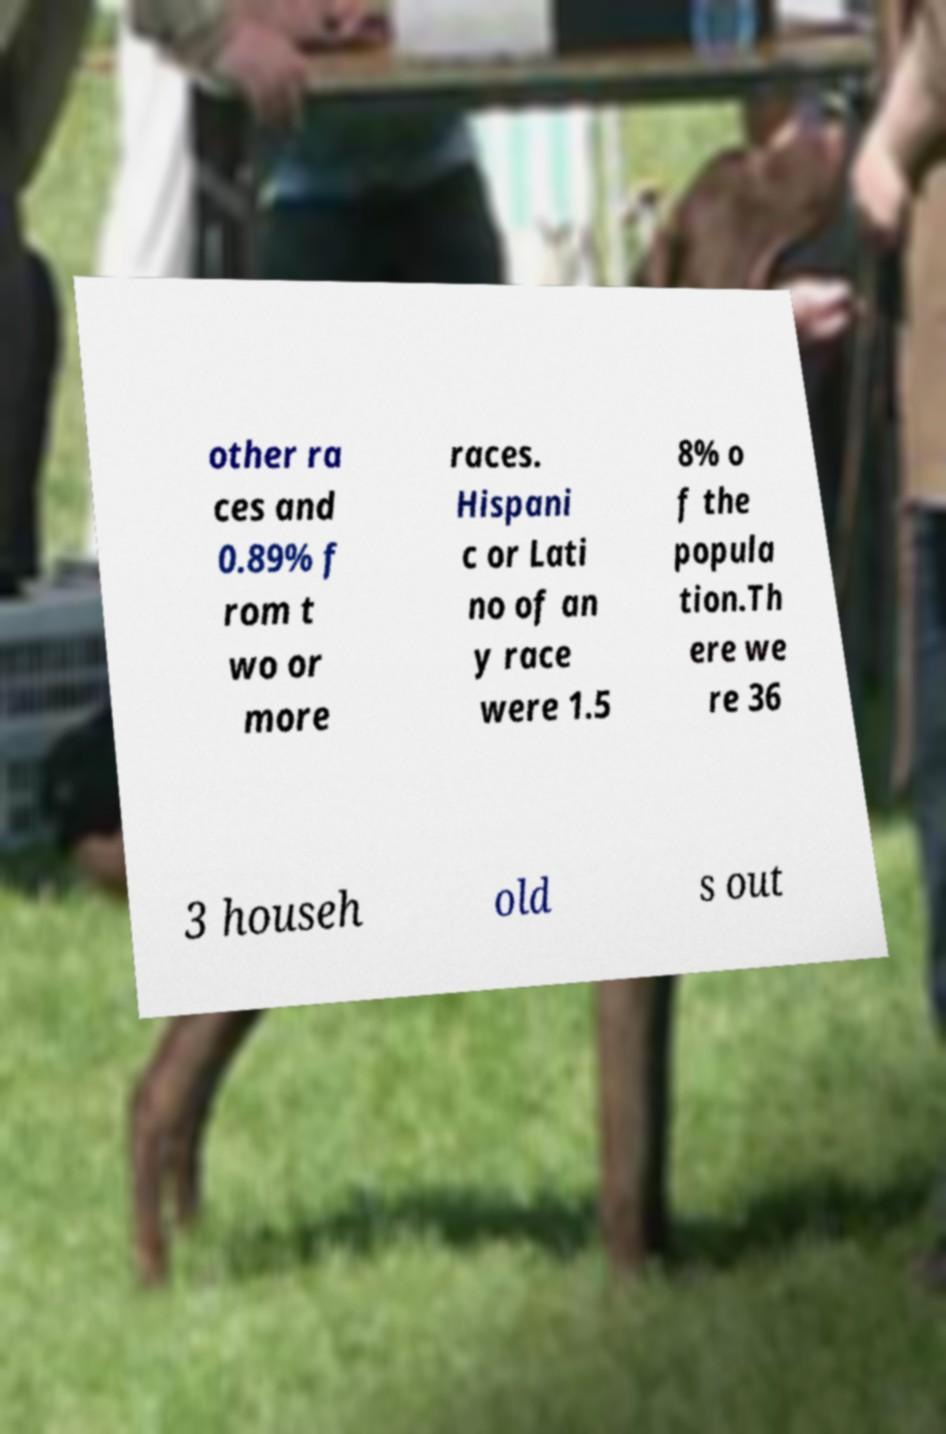Please read and relay the text visible in this image. What does it say? other ra ces and 0.89% f rom t wo or more races. Hispani c or Lati no of an y race were 1.5 8% o f the popula tion.Th ere we re 36 3 househ old s out 